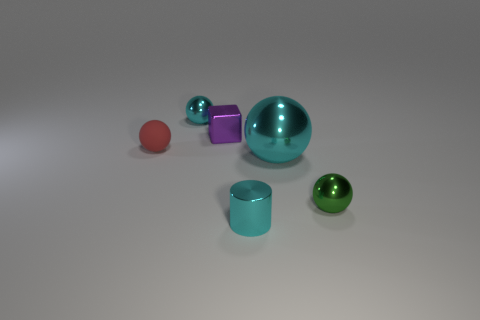Do the small green shiny object and the tiny rubber object have the same shape?
Provide a succinct answer. Yes. Is there any other thing that is the same size as the red rubber object?
Your response must be concise. Yes. There is a rubber ball; what number of tiny red rubber things are behind it?
Provide a succinct answer. 0. Does the cyan ball right of the shiny cylinder have the same size as the small purple cube?
Ensure brevity in your answer.  No. What is the color of the big metallic object that is the same shape as the small red thing?
Ensure brevity in your answer.  Cyan. Is there any other thing that is the same shape as the big metal object?
Give a very brief answer. Yes. There is a cyan metallic object behind the rubber sphere; what shape is it?
Keep it short and to the point. Sphere. What number of other large cyan things are the same shape as the large metallic object?
Your answer should be compact. 0. Is the color of the small object in front of the green ball the same as the small metallic sphere behind the red sphere?
Make the answer very short. Yes. How many objects are either tiny shiny balls or big gray spheres?
Provide a succinct answer. 2. 